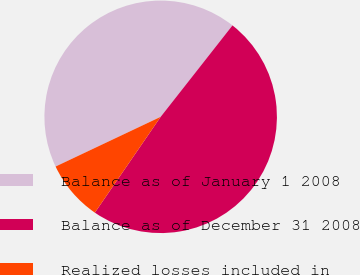Convert chart to OTSL. <chart><loc_0><loc_0><loc_500><loc_500><pie_chart><fcel>Balance as of January 1 2008<fcel>Balance as of December 31 2008<fcel>Realized losses included in<nl><fcel>42.63%<fcel>48.98%<fcel>8.39%<nl></chart> 